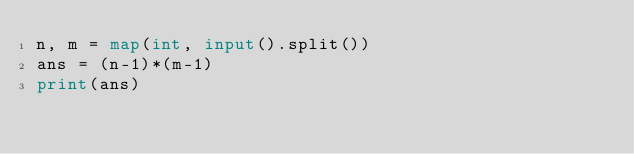Convert code to text. <code><loc_0><loc_0><loc_500><loc_500><_Python_>n, m = map(int, input().split())
ans = (n-1)*(m-1)
print(ans)</code> 